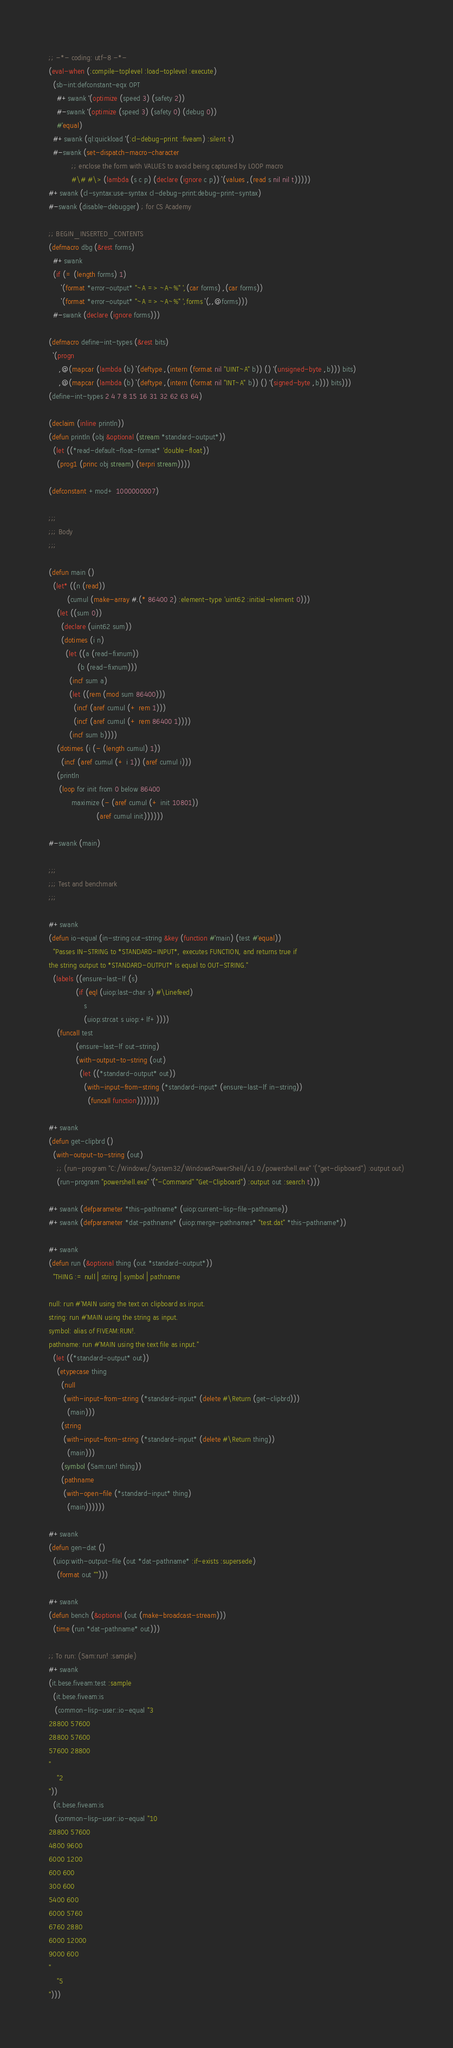Convert code to text. <code><loc_0><loc_0><loc_500><loc_500><_Lisp_>;; -*- coding: utf-8 -*-
(eval-when (:compile-toplevel :load-toplevel :execute)
  (sb-int:defconstant-eqx OPT
    #+swank '(optimize (speed 3) (safety 2))
    #-swank '(optimize (speed 3) (safety 0) (debug 0))
    #'equal)
  #+swank (ql:quickload '(:cl-debug-print :fiveam) :silent t)
  #-swank (set-dispatch-macro-character
           ;; enclose the form with VALUES to avoid being captured by LOOP macro
           #\# #\> (lambda (s c p) (declare (ignore c p)) `(values ,(read s nil nil t)))))
#+swank (cl-syntax:use-syntax cl-debug-print:debug-print-syntax)
#-swank (disable-debugger) ; for CS Academy

;; BEGIN_INSERTED_CONTENTS
(defmacro dbg (&rest forms)
  #+swank
  (if (= (length forms) 1)
      `(format *error-output* "~A => ~A~%" ',(car forms) ,(car forms))
      `(format *error-output* "~A => ~A~%" ',forms `(,,@forms)))
  #-swank (declare (ignore forms)))

(defmacro define-int-types (&rest bits)
  `(progn
     ,@(mapcar (lambda (b) `(deftype ,(intern (format nil "UINT~A" b)) () '(unsigned-byte ,b))) bits)
     ,@(mapcar (lambda (b) `(deftype ,(intern (format nil "INT~A" b)) () '(signed-byte ,b))) bits)))
(define-int-types 2 4 7 8 15 16 31 32 62 63 64)

(declaim (inline println))
(defun println (obj &optional (stream *standard-output*))
  (let ((*read-default-float-format* 'double-float))
    (prog1 (princ obj stream) (terpri stream))))

(defconstant +mod+ 1000000007)

;;;
;;; Body
;;;

(defun main ()
  (let* ((n (read))
         (cumul (make-array #.(* 86400 2) :element-type 'uint62 :initial-element 0)))
    (let ((sum 0))
      (declare (uint62 sum))
      (dotimes (i n)
        (let ((a (read-fixnum))
              (b (read-fixnum)))
          (incf sum a)
          (let ((rem (mod sum 86400)))
            (incf (aref cumul (+ rem 1)))
            (incf (aref cumul (+ rem 86400 1))))
          (incf sum b))))
    (dotimes (i (- (length cumul) 1))
      (incf (aref cumul (+ i 1)) (aref cumul i)))
    (println
     (loop for init from 0 below 86400
           maximize (- (aref cumul (+ init 10801))
                       (aref cumul init))))))

#-swank (main)

;;;
;;; Test and benchmark
;;;

#+swank
(defun io-equal (in-string out-string &key (function #'main) (test #'equal))
  "Passes IN-STRING to *STANDARD-INPUT*, executes FUNCTION, and returns true if
the string output to *STANDARD-OUTPUT* is equal to OUT-STRING."
  (labels ((ensure-last-lf (s)
             (if (eql (uiop:last-char s) #\Linefeed)
                 s
                 (uiop:strcat s uiop:+lf+))))
    (funcall test
             (ensure-last-lf out-string)
             (with-output-to-string (out)
               (let ((*standard-output* out))
                 (with-input-from-string (*standard-input* (ensure-last-lf in-string))
                   (funcall function)))))))

#+swank
(defun get-clipbrd ()
  (with-output-to-string (out)
    ;; (run-program "C:/Windows/System32/WindowsPowerShell/v1.0/powershell.exe" '("get-clipboard") :output out)
    (run-program "powershell.exe" '("-Command" "Get-Clipboard") :output out :search t)))

#+swank (defparameter *this-pathname* (uiop:current-lisp-file-pathname))
#+swank (defparameter *dat-pathname* (uiop:merge-pathnames* "test.dat" *this-pathname*))

#+swank
(defun run (&optional thing (out *standard-output*))
  "THING := null | string | symbol | pathname

null: run #'MAIN using the text on clipboard as input.
string: run #'MAIN using the string as input.
symbol: alias of FIVEAM:RUN!.
pathname: run #'MAIN using the text file as input."
  (let ((*standard-output* out))
    (etypecase thing
      (null
       (with-input-from-string (*standard-input* (delete #\Return (get-clipbrd)))
         (main)))
      (string
       (with-input-from-string (*standard-input* (delete #\Return thing))
         (main)))
      (symbol (5am:run! thing))
      (pathname
       (with-open-file (*standard-input* thing)
         (main))))))

#+swank
(defun gen-dat ()
  (uiop:with-output-file (out *dat-pathname* :if-exists :supersede)
    (format out "")))

#+swank
(defun bench (&optional (out (make-broadcast-stream)))
  (time (run *dat-pathname* out)))

;; To run: (5am:run! :sample)
#+swank
(it.bese.fiveam:test :sample
  (it.bese.fiveam:is
   (common-lisp-user::io-equal "3
28800 57600
28800 57600
57600 28800
"
    "2
"))
  (it.bese.fiveam:is
   (common-lisp-user::io-equal "10
28800 57600
4800 9600
6000 1200
600 600
300 600
5400 600
6000 5760
6760 2880
6000 12000
9000 600
"
    "5
")))
</code> 